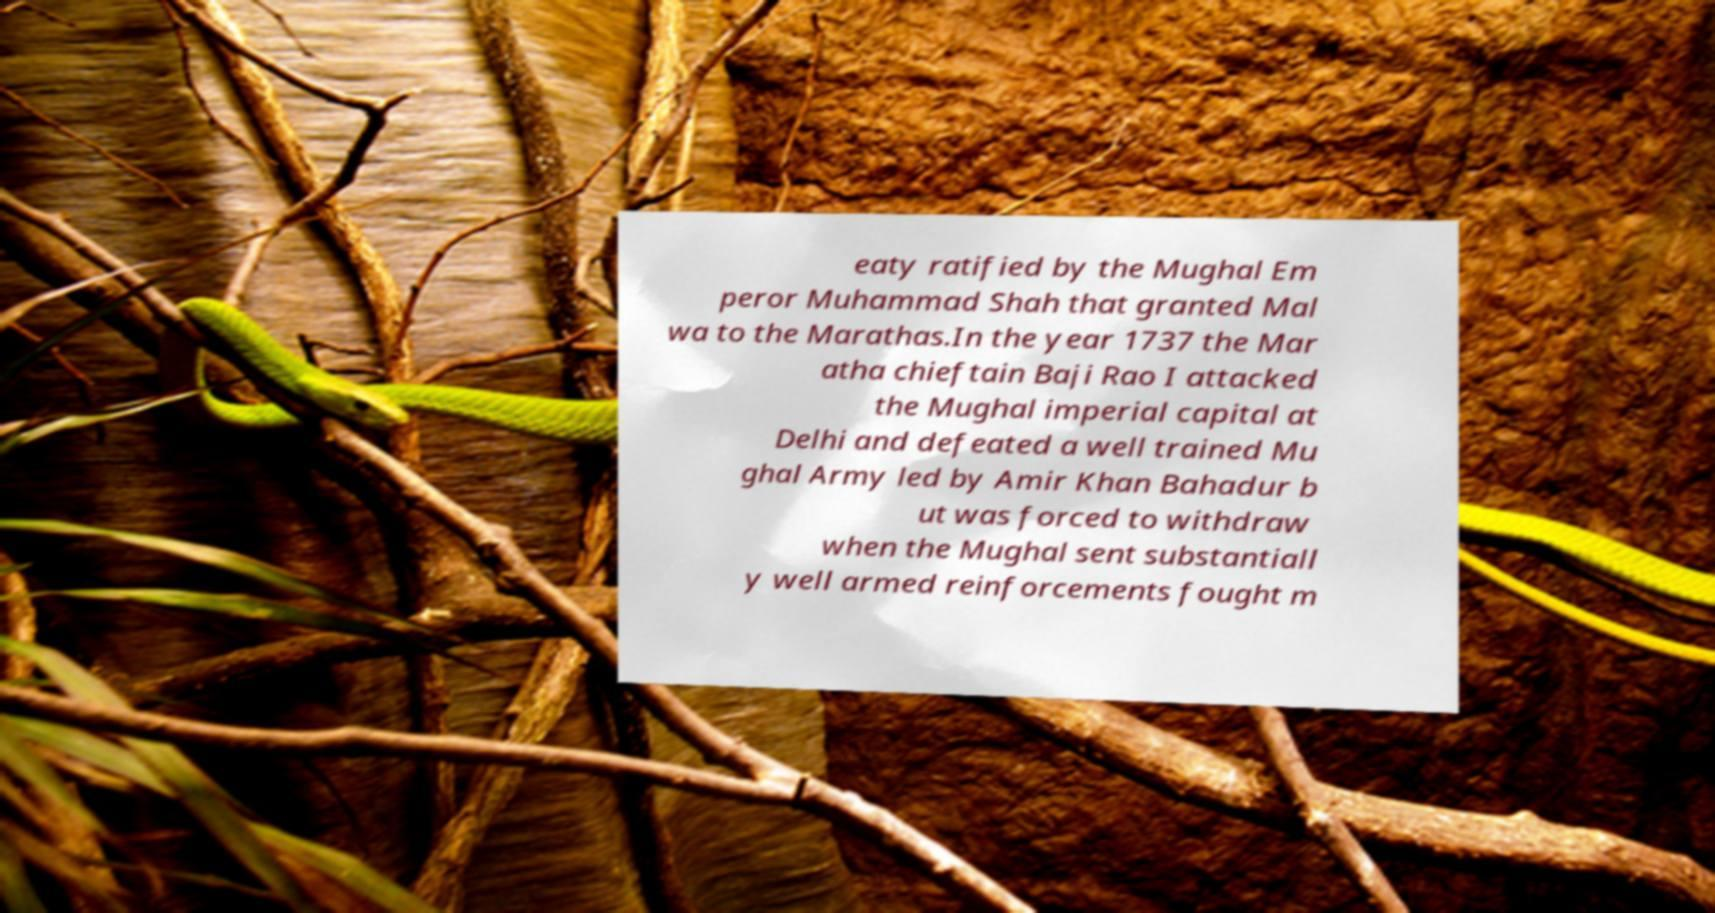For documentation purposes, I need the text within this image transcribed. Could you provide that? eaty ratified by the Mughal Em peror Muhammad Shah that granted Mal wa to the Marathas.In the year 1737 the Mar atha chieftain Baji Rao I attacked the Mughal imperial capital at Delhi and defeated a well trained Mu ghal Army led by Amir Khan Bahadur b ut was forced to withdraw when the Mughal sent substantiall y well armed reinforcements fought m 